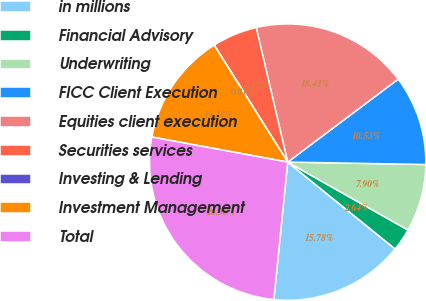Convert chart to OTSL. <chart><loc_0><loc_0><loc_500><loc_500><pie_chart><fcel>in millions<fcel>Financial Advisory<fcel>Underwriting<fcel>FICC Client Execution<fcel>Equities client execution<fcel>Securities services<fcel>Investing & Lending<fcel>Investment Management<fcel>Total<nl><fcel>15.78%<fcel>2.64%<fcel>7.9%<fcel>10.53%<fcel>18.41%<fcel>5.27%<fcel>0.01%<fcel>13.16%<fcel>26.3%<nl></chart> 